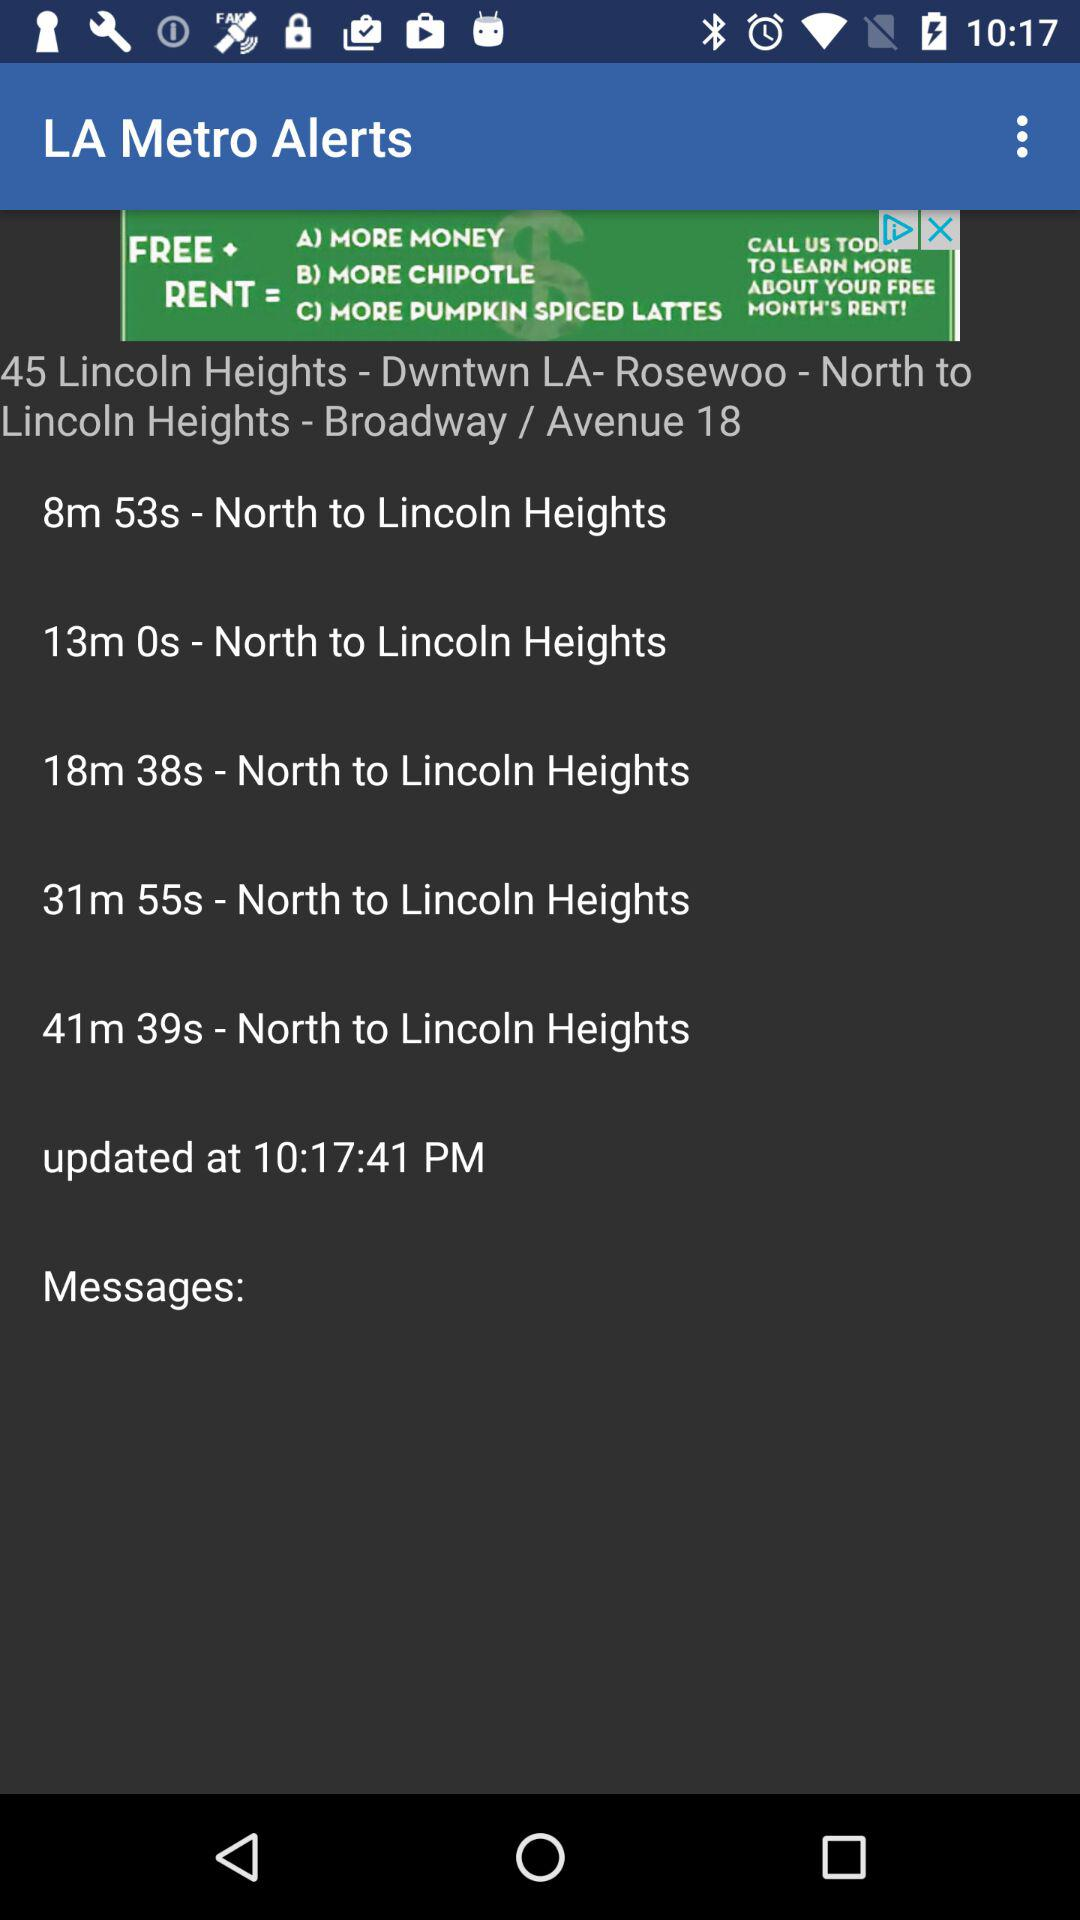What is the time? The time is 10:17:41 PM. 